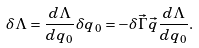<formula> <loc_0><loc_0><loc_500><loc_500>\delta \Lambda = \frac { d \Lambda } { d q _ { 0 } } \delta q _ { 0 } = - \delta \vec { \Gamma } \vec { q } \frac { d \Lambda } { d q _ { 0 } } .</formula> 